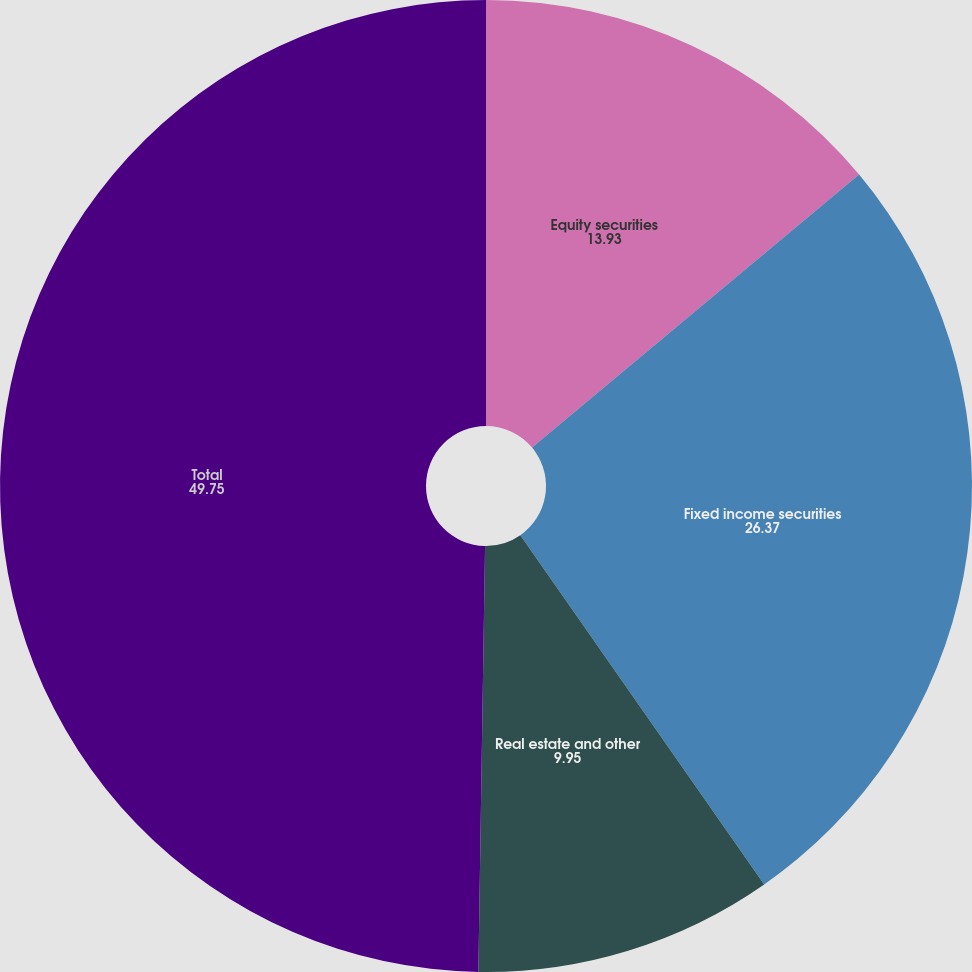<chart> <loc_0><loc_0><loc_500><loc_500><pie_chart><fcel>Equity securities<fcel>Fixed income securities<fcel>Real estate and other<fcel>Total<nl><fcel>13.93%<fcel>26.37%<fcel>9.95%<fcel>49.75%<nl></chart> 